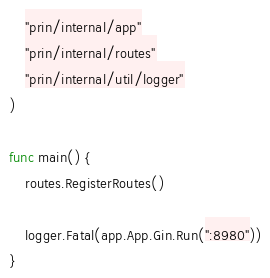Convert code to text. <code><loc_0><loc_0><loc_500><loc_500><_Go_>	"prin/internal/app"
	"prin/internal/routes"
	"prin/internal/util/logger"
)

func main() {
	routes.RegisterRoutes()

	logger.Fatal(app.App.Gin.Run(":8980"))
}
</code> 